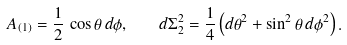<formula> <loc_0><loc_0><loc_500><loc_500>A _ { ( 1 ) } = \frac { 1 } { 2 } \, \cos \theta \, d \phi , \quad d \Sigma _ { 2 } ^ { 2 } = \frac { 1 } { 4 } \left ( d \theta ^ { 2 } + \sin ^ { 2 } \theta \, d \phi ^ { 2 } \right ) .</formula> 